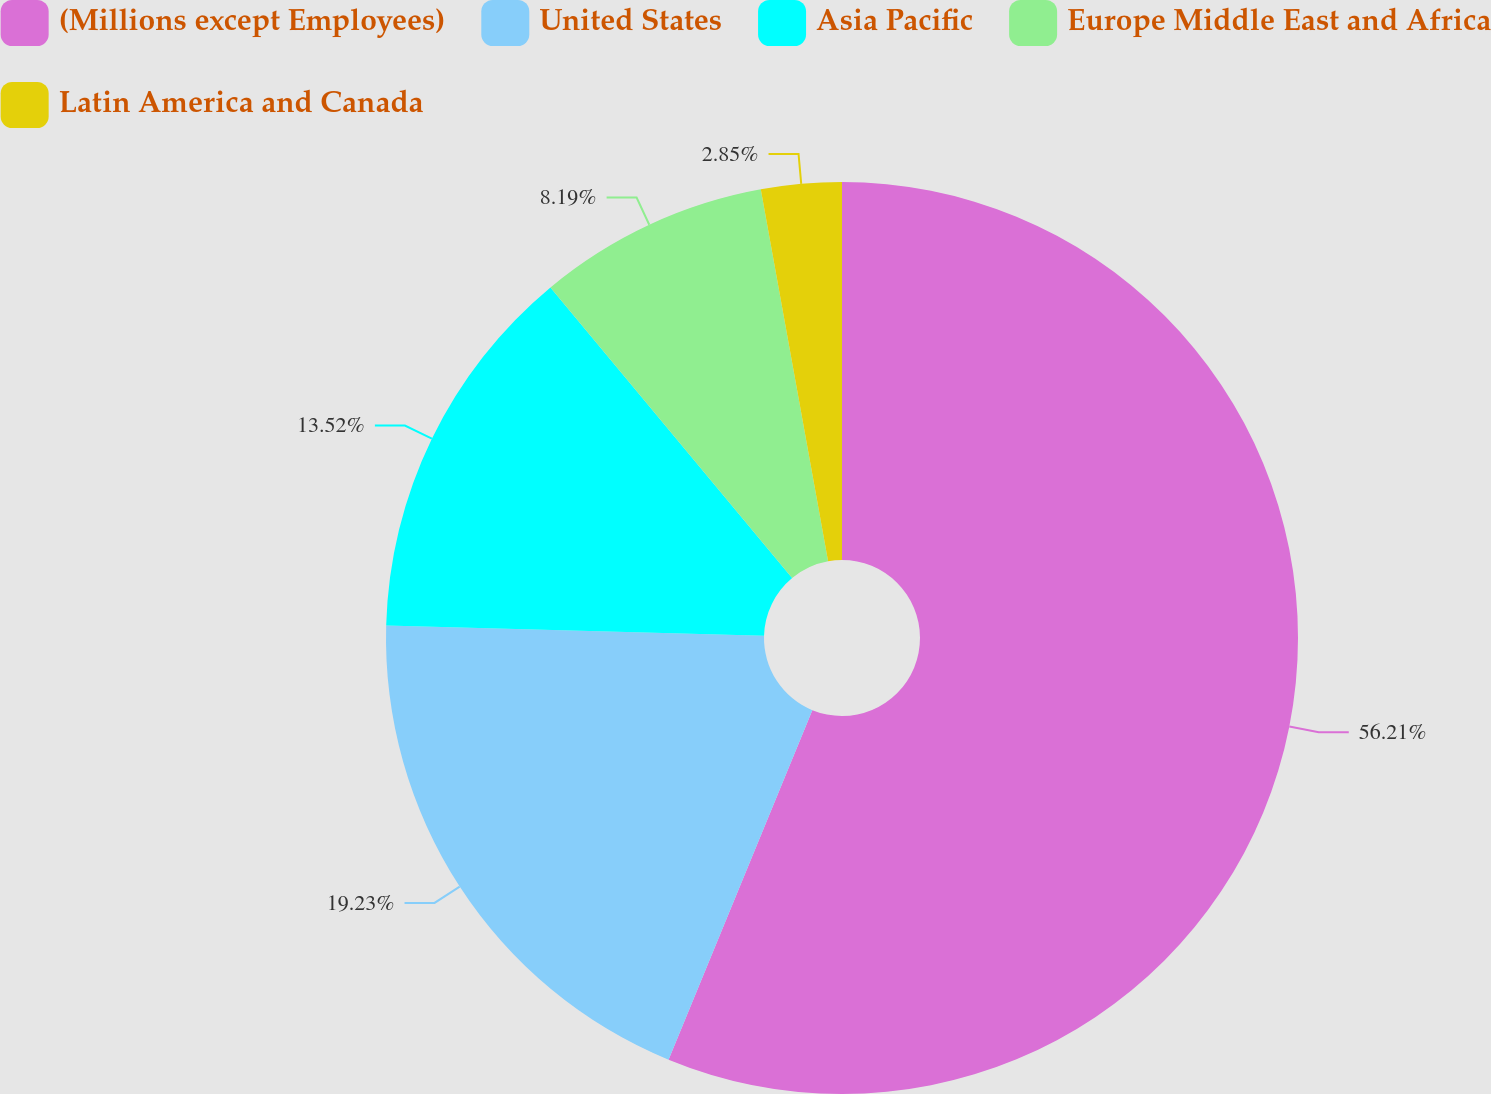Convert chart. <chart><loc_0><loc_0><loc_500><loc_500><pie_chart><fcel>(Millions except Employees)<fcel>United States<fcel>Asia Pacific<fcel>Europe Middle East and Africa<fcel>Latin America and Canada<nl><fcel>56.21%<fcel>19.23%<fcel>13.52%<fcel>8.19%<fcel>2.85%<nl></chart> 